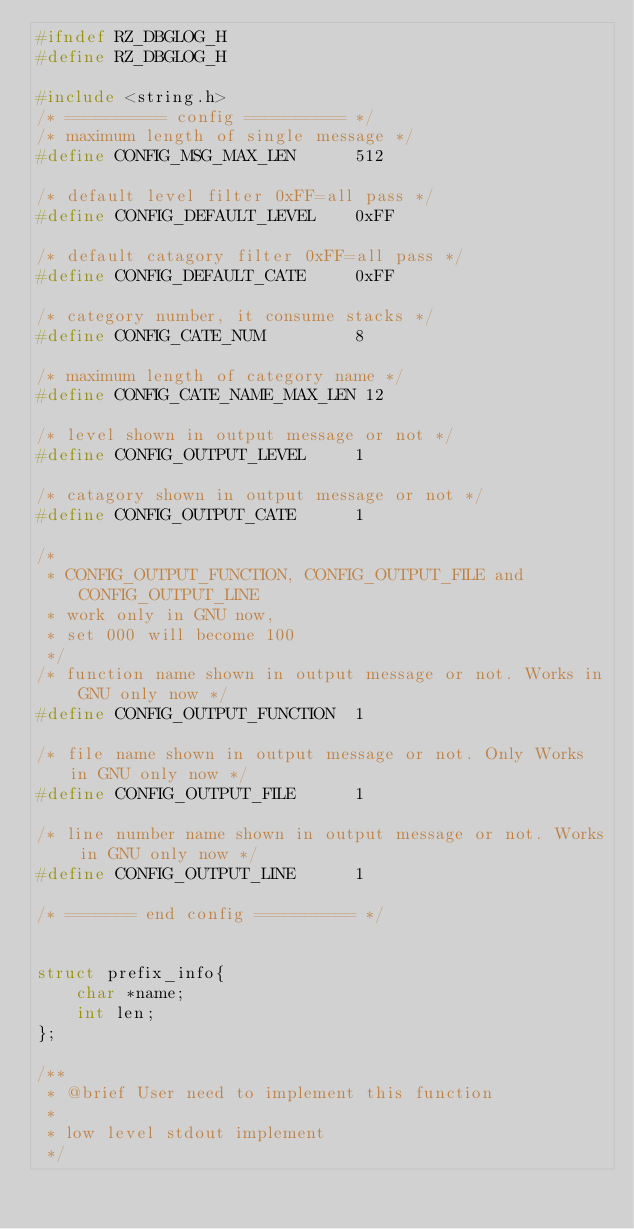Convert code to text. <code><loc_0><loc_0><loc_500><loc_500><_C_>#ifndef RZ_DBGLOG_H
#define RZ_DBGLOG_H

#include <string.h>
/* ========== config ========== */
/* maximum length of single message */
#define CONFIG_MSG_MAX_LEN      512

/* default level filter 0xFF=all pass */
#define CONFIG_DEFAULT_LEVEL    0xFF

/* default catagory filter 0xFF=all pass */
#define CONFIG_DEFAULT_CATE     0xFF

/* category number, it consume stacks */
#define CONFIG_CATE_NUM         8

/* maximum length of category name */
#define CONFIG_CATE_NAME_MAX_LEN 12

/* level shown in output message or not */
#define CONFIG_OUTPUT_LEVEL     1

/* catagory shown in output message or not */
#define CONFIG_OUTPUT_CATE      1

/*
 * CONFIG_OUTPUT_FUNCTION, CONFIG_OUTPUT_FILE and CONFIG_OUTPUT_LINE
 * work only in GNU now,
 * set 000 will become 100
 */
/* function name shown in output message or not. Works in GNU only now */
#define CONFIG_OUTPUT_FUNCTION  1

/* file name shown in output message or not. Only Works in GNU only now */
#define CONFIG_OUTPUT_FILE      1

/* line number name shown in output message or not. Works in GNU only now */
#define CONFIG_OUTPUT_LINE      1

/* ======= end config ========== */


struct prefix_info{
    char *name;
    int len;
};

/**
 * @brief User need to implement this function
 *
 * low level stdout implement
 */</code> 